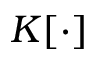<formula> <loc_0><loc_0><loc_500><loc_500>K [ \cdot ]</formula> 